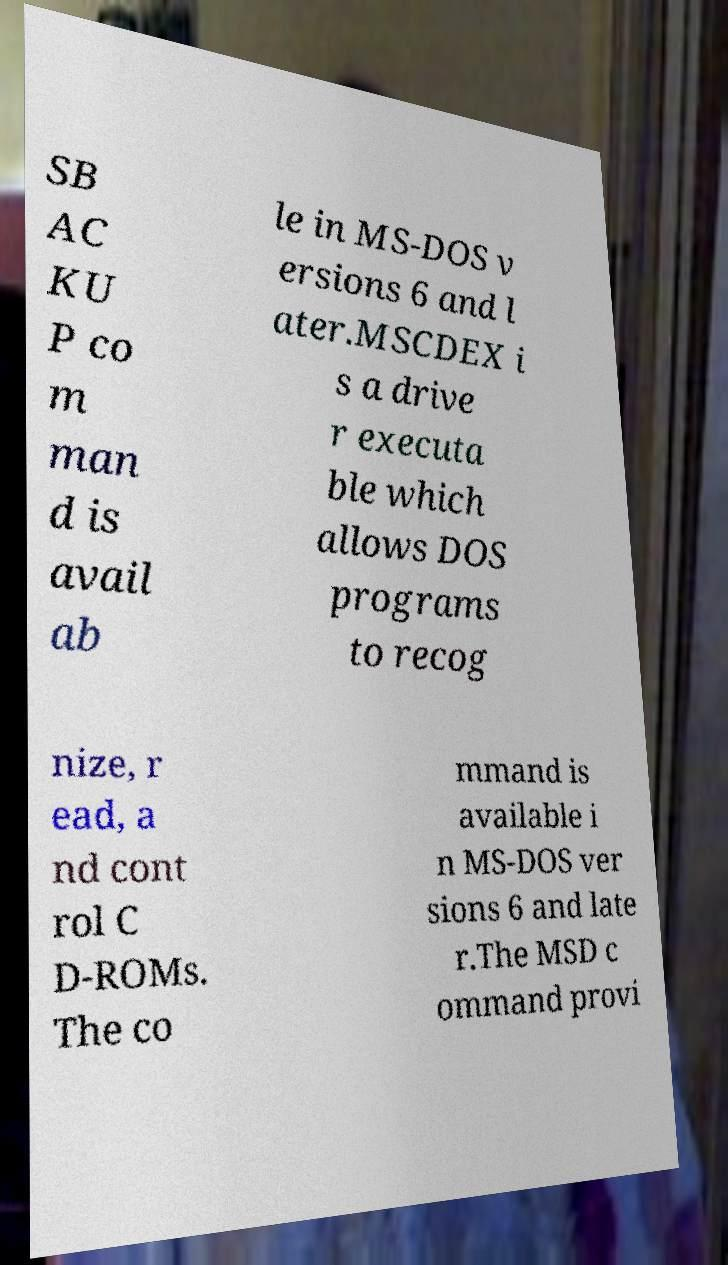There's text embedded in this image that I need extracted. Can you transcribe it verbatim? SB AC KU P co m man d is avail ab le in MS-DOS v ersions 6 and l ater.MSCDEX i s a drive r executa ble which allows DOS programs to recog nize, r ead, a nd cont rol C D-ROMs. The co mmand is available i n MS-DOS ver sions 6 and late r.The MSD c ommand provi 